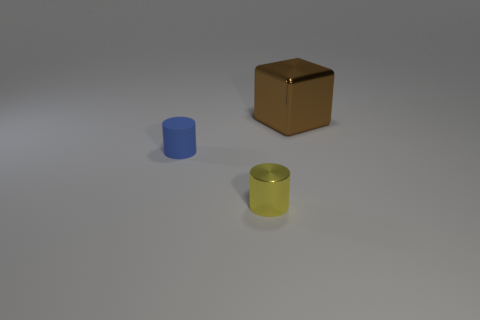Are there any other things that have the same size as the brown block?
Your response must be concise. No. Does the shiny object that is in front of the large block have the same size as the shiny object that is behind the yellow object?
Offer a terse response. No. Are there any tiny yellow things made of the same material as the large brown object?
Your answer should be compact. Yes. There is a thing behind the tiny cylinder that is behind the tiny yellow metallic thing; are there any brown things that are behind it?
Your response must be concise. No. There is a tiny yellow metallic cylinder; are there any blue objects to the left of it?
Give a very brief answer. Yes. There is a tiny cylinder that is behind the tiny shiny cylinder; how many small blue cylinders are left of it?
Keep it short and to the point. 0. There is a brown cube; is its size the same as the cylinder in front of the tiny blue matte cylinder?
Your answer should be compact. No. There is a brown thing that is the same material as the small yellow thing; what is its size?
Provide a short and direct response. Large. Is the material of the yellow cylinder the same as the large block?
Ensure brevity in your answer.  Yes. What color is the thing that is behind the object on the left side of the shiny object left of the large brown metallic thing?
Your response must be concise. Brown. 